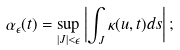Convert formula to latex. <formula><loc_0><loc_0><loc_500><loc_500>\alpha _ { \epsilon } ( t ) = \sup _ { | J | < \epsilon } \left | \int _ { J } \kappa ( u , t ) d s \right | ;</formula> 